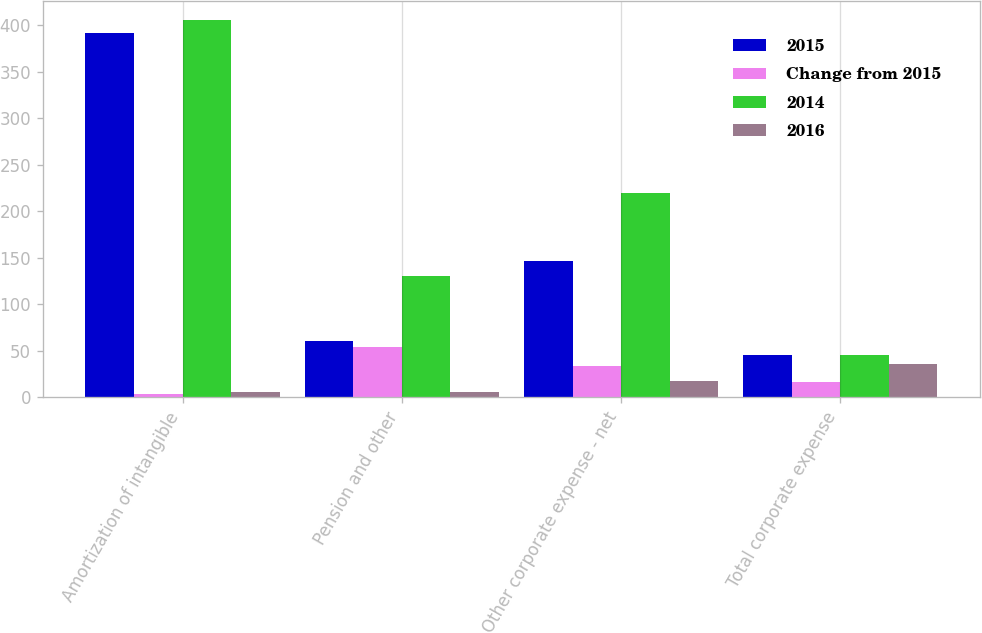<chart> <loc_0><loc_0><loc_500><loc_500><stacked_bar_chart><ecel><fcel>Amortization of intangible<fcel>Pension and other<fcel>Other corporate expense - net<fcel>Total corporate expense<nl><fcel>2015<fcel>392<fcel>60<fcel>146<fcel>45<nl><fcel>Change from 2015<fcel>3<fcel>54<fcel>34<fcel>16<nl><fcel>2014<fcel>406<fcel>130<fcel>220<fcel>45<nl><fcel>2016<fcel>6<fcel>6<fcel>17<fcel>36<nl></chart> 